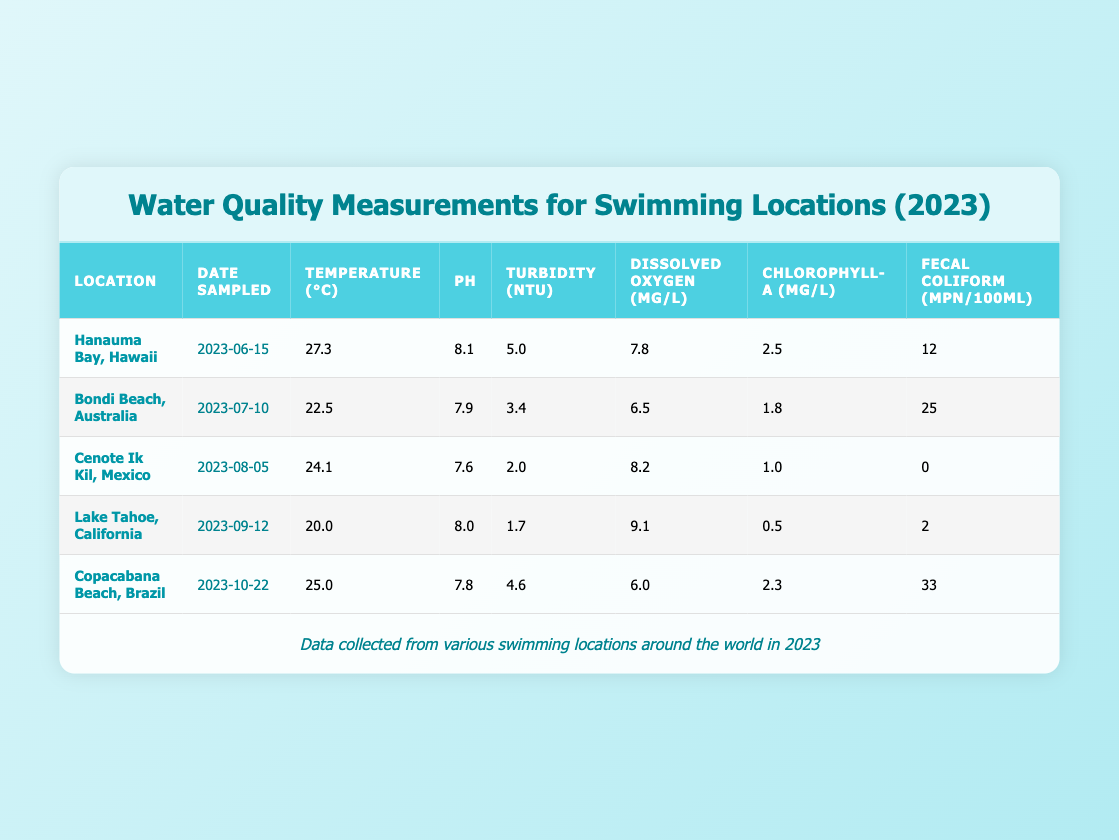What is the temperature at Lake Tahoe, California? By referring to the table, I can see that the temperature recorded for Lake Tahoe, California is 20.0 °C on the sampled date, which is September 12, 2023.
Answer: 20.0 °C What is the pH level of Copacabana Beach, Brazil? The table indicates that the pH level for Copacabana Beach, Brazil, which was sampled on October 22, 2023, is 7.8.
Answer: 7.8 Which location had the highest fecal coliform levels and what was the value? Reviewing the table, I find that Copacabana Beach, Brazil has the highest fecal coliform levels at a value of 33 MPN/100mL, as compared to other locations.
Answer: 33 What is the average temperature of the five locations sampled? To find the average temperature, I add the temperatures of all locations: 27.3 + 22.5 + 24.1 + 20.0 + 25.0 = 119.9 °C. Then, I divide this sum by the number of locations, which is 5. Therefore, the average temperature is 119.9/5 = 23.98 °C.
Answer: 23.98 °C Is the turbidity level at Cenote Ik Kil, Mexico higher or lower than that at Bondi Beach, Australia? Looking at the table, the turbidity level at Cenote Ik Kil is 2.0 NTU while Bondi Beach has a turbidity level of 3.4 NTU. Since 2.0 NTU is less than 3.4 NTU, it is clear that the turbidity level at Cenote Ik Kil is lower than at Bondi Beach.
Answer: Lower Was the dissolved oxygen level at Hanauma Bay, Hawaii higher than the average dissolved oxygen level of all locations? First, I find the dissolved oxygen levels from each location: 7.8 (Hanauma Bay) + 6.5 (Bondi Beach) + 8.2 (Cenote Ik Kil) + 9.1 (Lake Tahoe) + 6.0 (Copacabana Beach) = 37.6 mg/L. Then, dividing by 5 gives an average of 7.52 mg/L. Since 7.8 mg/L (Hanauma Bay) is greater than the average of 7.52 mg/L, the answer is yes.
Answer: Yes What is the difference in chlorophyll-a levels between Lake Tahoe, California and Copacabana Beach, Brazil? Based on the data, Lake Tahoe has chlorophyll-a levels of 0.5 µg/L and Copacabana Beach has 2.3 µg/L. To find the difference: 2.3 - 0.5 = 1.8 µg/L. This shows that Copacabana Beach has 1.8 µg/L more chlorophyll-a than Lake Tahoe.
Answer: 1.8 µg/L Is the pH level at Cenote Ik Kil, Mexico above 7.5? The pH level at Cenote Ik Kil is 7.6, which is indeed above 7.5. Thus, the answer to whether it is above 7.5 is yes.
Answer: Yes Which location had the highest dissolved oxygen level and what was the reading? Looking through the data, Lake Tahoe, California has the highest dissolved oxygen level of 9.1 mg/L on September 12, 2023, making it the highest among all 5 locations.
Answer: 9.1 mg/L 